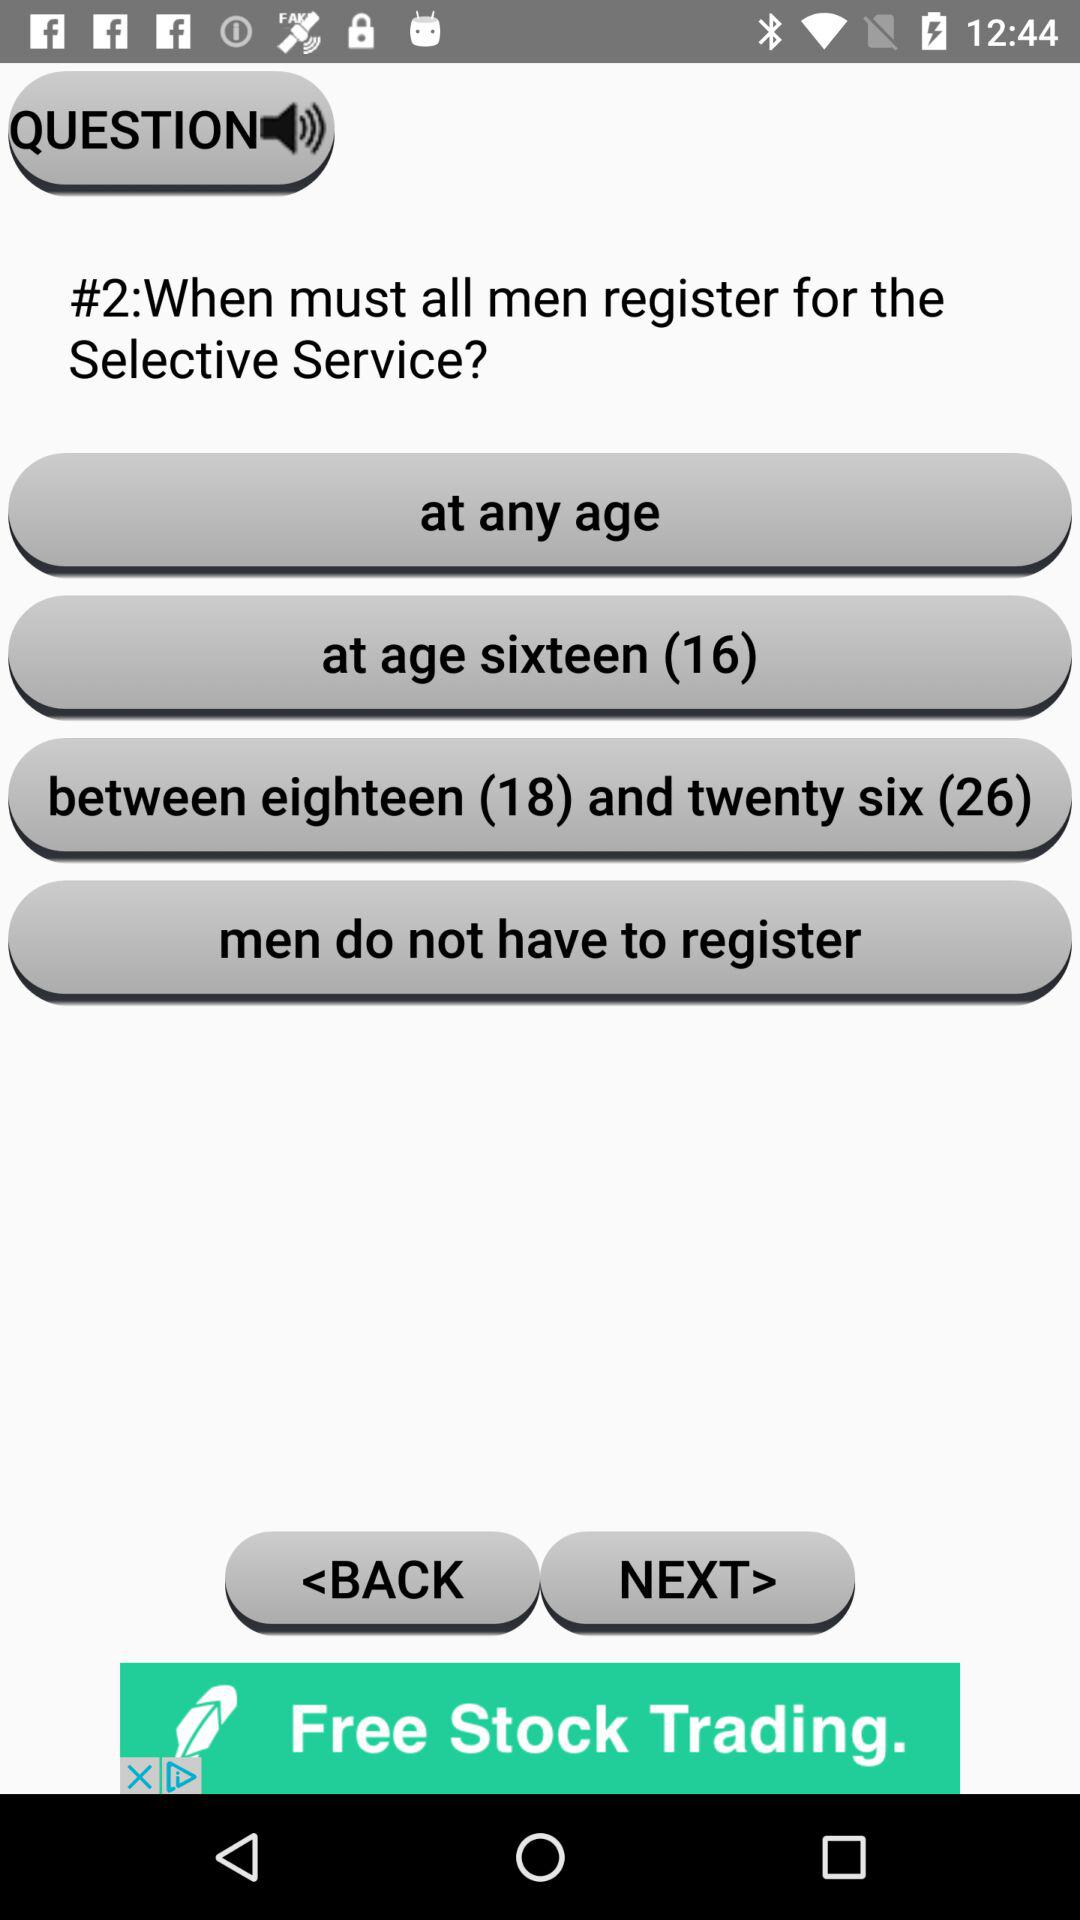How many options are there for the age at which men must register for the Selective Service?
Answer the question using a single word or phrase. 4 